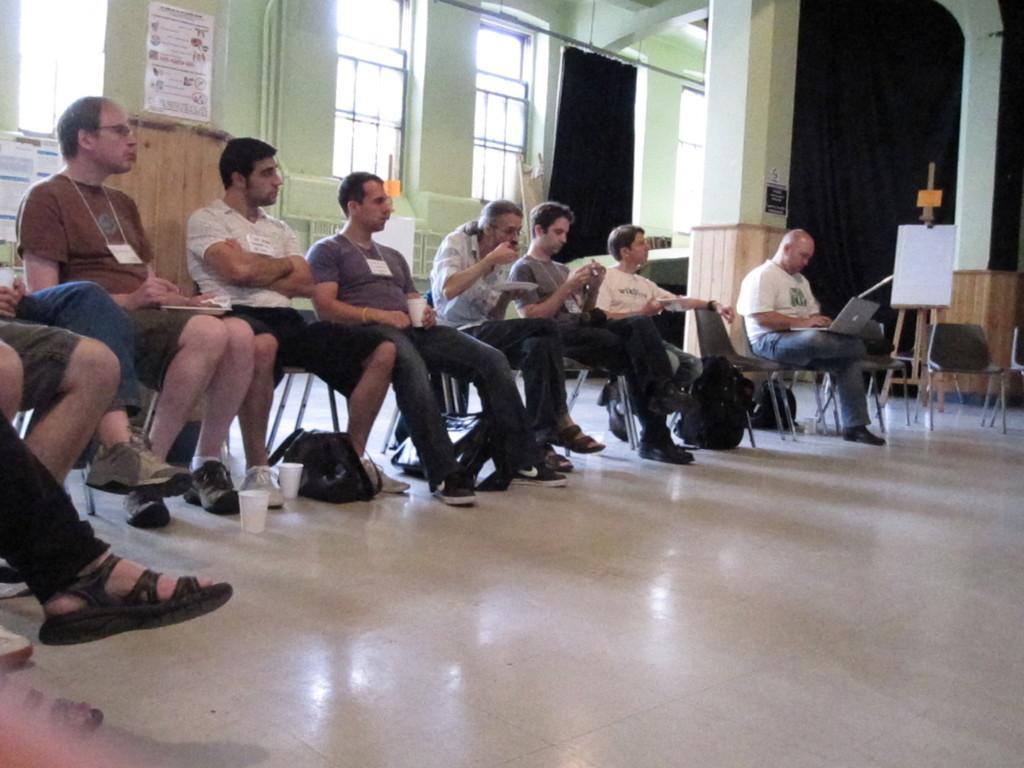How would you summarize this image in a sentence or two? In this picture I can observe some men sitting in the chairs. All of them are wearing tags in their necks. I can observe white color cups on the floor. On the right side there is a board fixed to the stand. In the background there is a black color curtain and windows. 